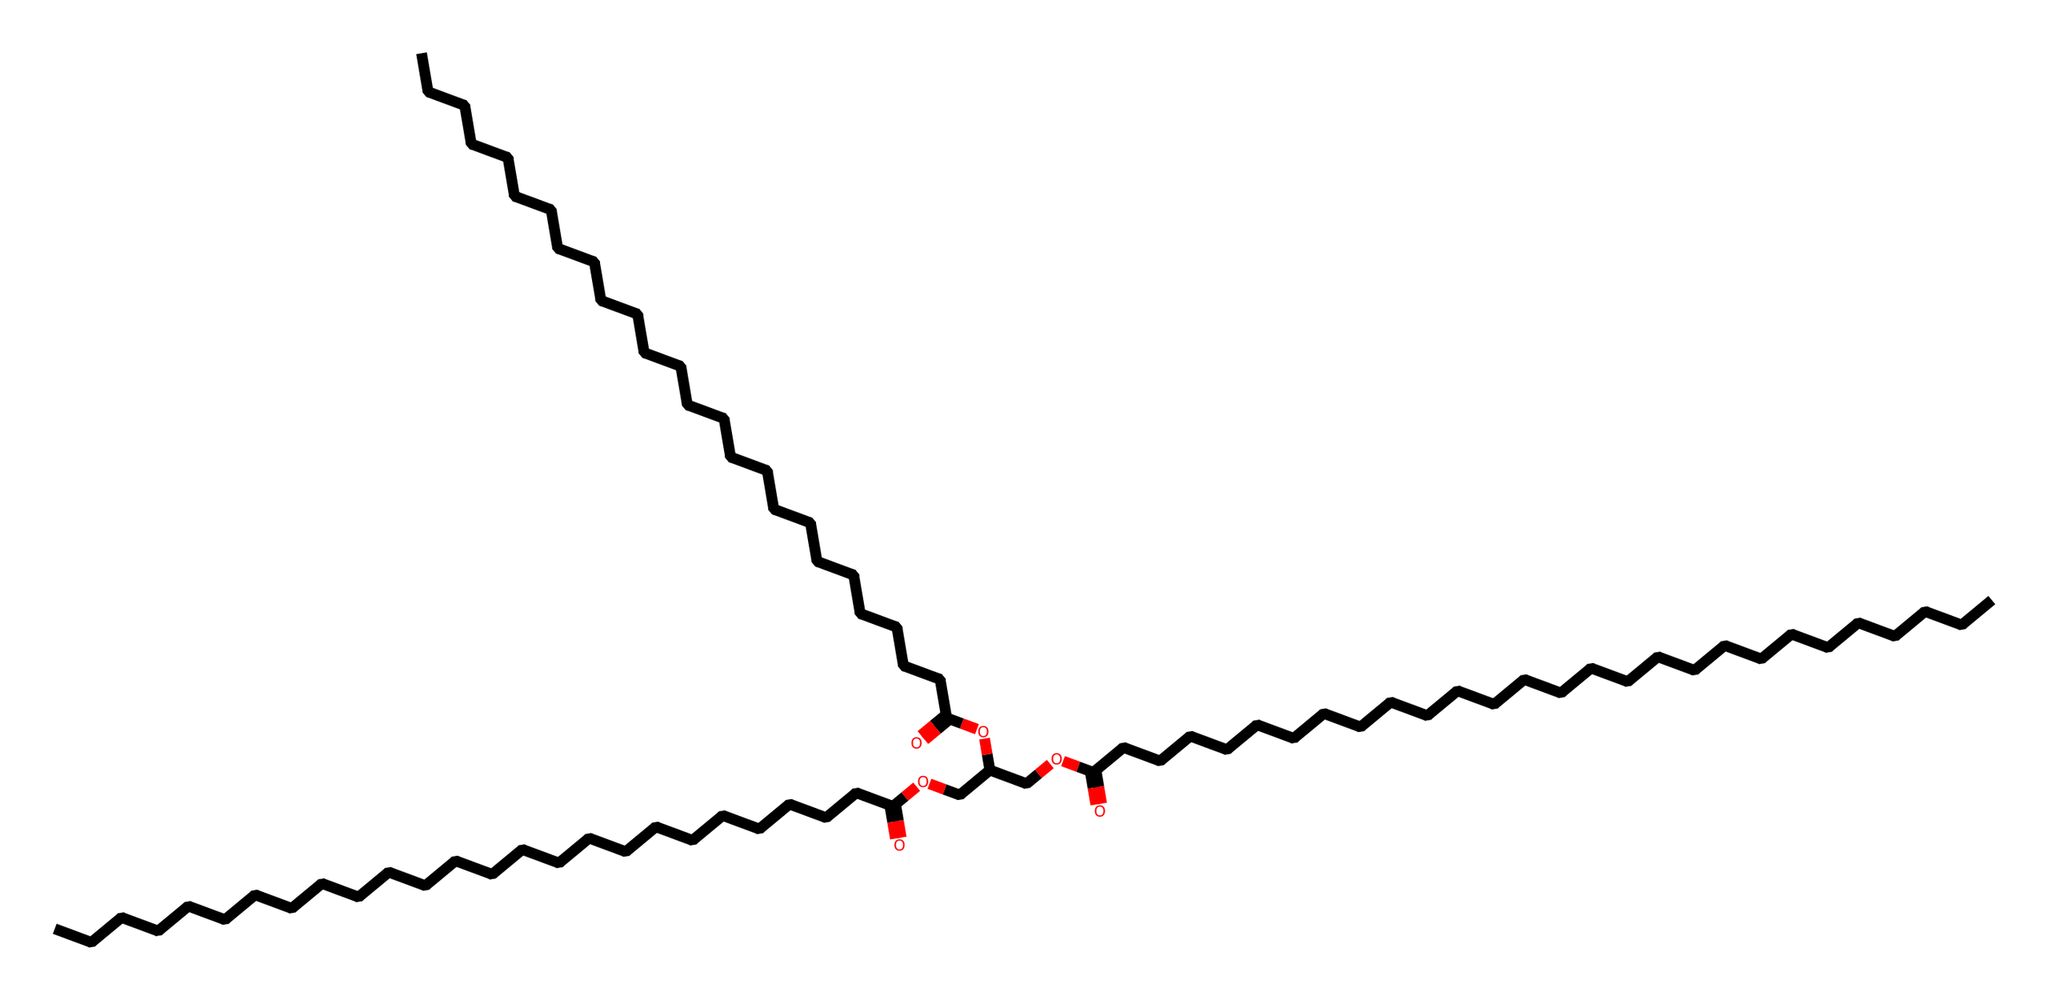how many carbon atoms are present in this ester? By analyzing the SMILES representation, we can identify the chains of carbon atoms throughout the structure. Each "C" indicates a carbon atom, and there are a total of 27 carbon atoms when counted in the full structure.
Answer: 27 what type of functional group is present in this chemical? The SMILES representation contains the signature "O" along with "OCC" and the ester bond indicated by "C(=O)O." This points to the presence of ester functional groups.
Answer: ester how many ester groups are present in this molecule? The structure has three instances of "C(=O)O," which indicates three ester functionalities. Each of these corresponds to a distinct ester bond.
Answer: 3 what is the general formula of this type of ester? Esters generally follow the formula RCOOR', where R and R' are hydrocarbon groups. Analyzing the structure, it maintains that pattern confirming it fits the general ester formula.
Answer: RCOOR' what is the main source of wax used in traditional Mediterranean candle-making? The main source of wax for these candles comes from beeswax, which consists mainly of esters. The long-chain fatty acids and fatty alcohols contribute to its structure, which aligns with the composition identified in the SMILES.
Answer: beeswax 